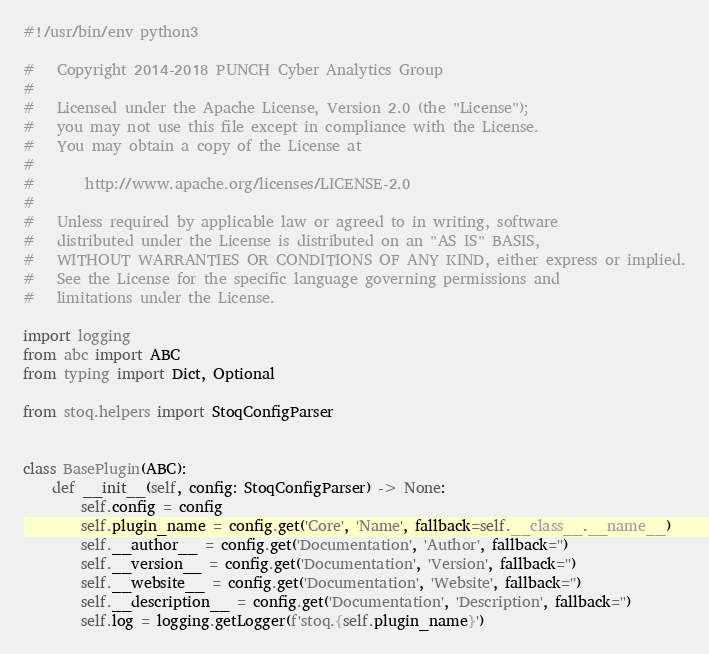Convert code to text. <code><loc_0><loc_0><loc_500><loc_500><_Python_>#!/usr/bin/env python3

#   Copyright 2014-2018 PUNCH Cyber Analytics Group
#
#   Licensed under the Apache License, Version 2.0 (the "License");
#   you may not use this file except in compliance with the License.
#   You may obtain a copy of the License at
#
#       http://www.apache.org/licenses/LICENSE-2.0
#
#   Unless required by applicable law or agreed to in writing, software
#   distributed under the License is distributed on an "AS IS" BASIS,
#   WITHOUT WARRANTIES OR CONDITIONS OF ANY KIND, either express or implied.
#   See the License for the specific language governing permissions and
#   limitations under the License.

import logging
from abc import ABC
from typing import Dict, Optional

from stoq.helpers import StoqConfigParser


class BasePlugin(ABC):
    def __init__(self, config: StoqConfigParser) -> None:
        self.config = config
        self.plugin_name = config.get('Core', 'Name', fallback=self.__class__.__name__)
        self.__author__ = config.get('Documentation', 'Author', fallback='')
        self.__version__ = config.get('Documentation', 'Version', fallback='')
        self.__website__ = config.get('Documentation', 'Website', fallback='')
        self.__description__ = config.get('Documentation', 'Description', fallback='')
        self.log = logging.getLogger(f'stoq.{self.plugin_name}')
</code> 